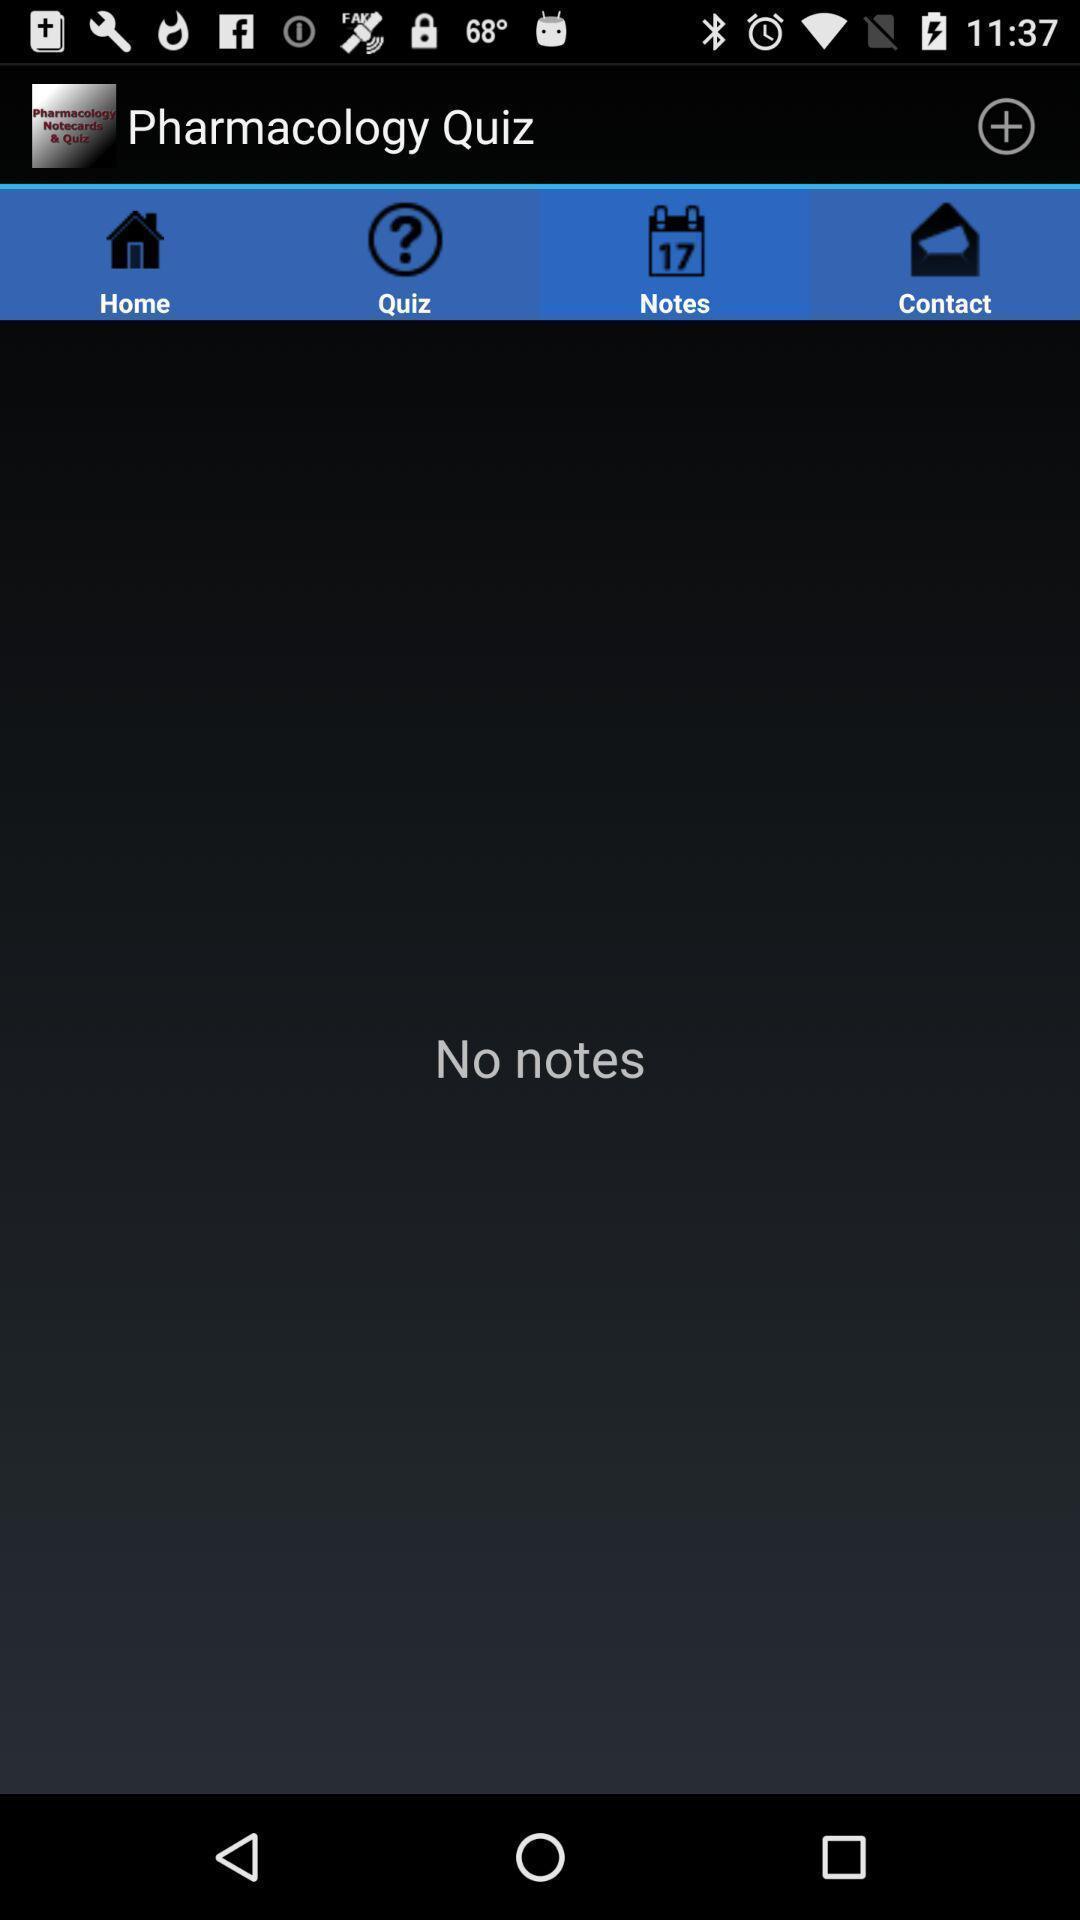Describe the visual elements of this screenshot. Page displaying the notes of the quiz. 